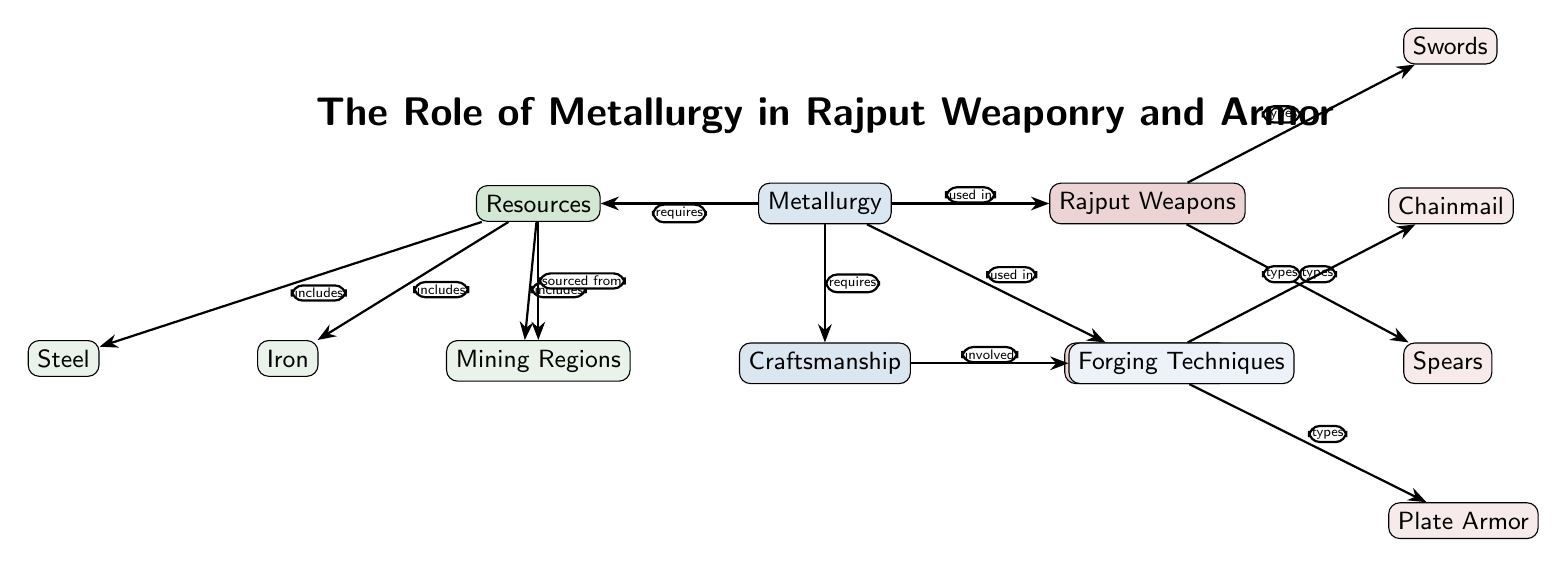What type of tools are classified under Rajput Weapons? The diagram specifies "Swords" and "Spears" as the types of tools categorized under Rajput Weapons, which are connected directly to the Rajput Weapons node.
Answer: Swords, Spears Which materials are included as resources in the diagram? "Iron," "Steel," and "Bronze" are listed as included materials under the Resources node, shown with direct connections.
Answer: Iron, Steel, Bronze What is the direct relationship between metallurgy and Rajput Armor? The diagram indicates that metallurgy is "used in" Rajput Armor, which describes the role metallurgy plays in crafting armor.
Answer: used in How many types of Rajput Armor are identified in the diagram? The diagram shows "Chainmail" and "Plate Armor" as the two types of Rajput Armor, which are directly connected to the Rajput Armor node.
Answer: 2 What techniques are involved in the craftsmanship according to the diagram? The diagram mentions "Forging Techniques" as the specific techniques involved in the craftsmanship, which is shown as connected to that node.
Answer: Forging Techniques Which regions are the resources sourced from? "Mining Regions" are specified in the diagram as the source of resources, indicated by the directed edge explaining the sourcing connection.
Answer: Mining Regions What must metallurgy require to function properly? The diagram highlights that metallurgy "requires" both resources and craftsmanship, depicting the foundational needs to engage in metallurgy.
Answer: Resources, Craftsmanship Which type of armor does not fall under the category of Rajput Weapons? The diagram clearly separates armor types from weapons, indicating that "Chainmail" and "Plate Armor" are not included in the Rajput Weapons node.
Answer: Chainmail, Plate Armor What color is used to represent Rajput Weapons in the diagram? The node representing Rajput Weapons is filled with a shade of Rajput red, distinguishing it visually from other categories.
Answer: Rajput red What connection is made between the resources and metallurgy? The diagram states that metallurgy "requires" resources, showing a relationship where resources are essential for metallurgical processes.
Answer: requires 